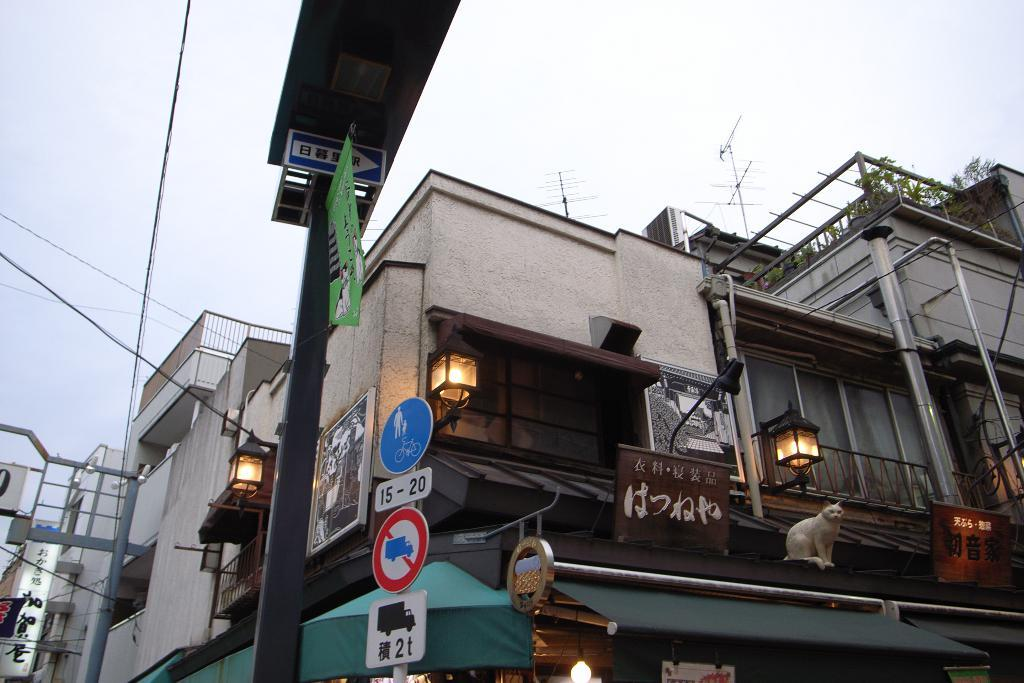What type of structures can be seen in the image? There are buildings in the image. What else is present in the image besides the buildings? Wires, lights, sign boards, and poles are visible in the image. Where are the lights located in the image? The lights are attached to the wall. What can be seen in the background of the image? The sky is visible in the background of the image. Is there a stream running through the image? No, there is no stream visible in the image. 